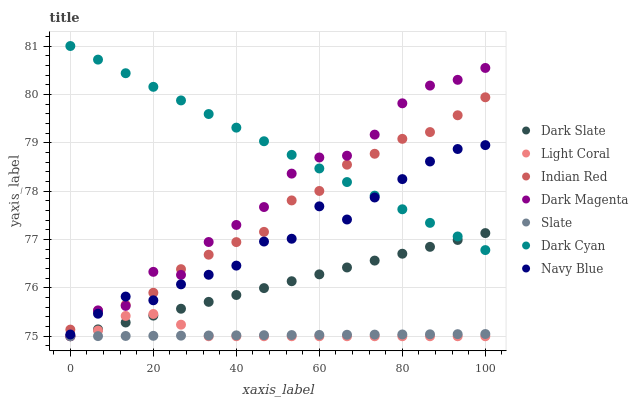Does Slate have the minimum area under the curve?
Answer yes or no. Yes. Does Dark Cyan have the maximum area under the curve?
Answer yes or no. Yes. Does Navy Blue have the minimum area under the curve?
Answer yes or no. No. Does Navy Blue have the maximum area under the curve?
Answer yes or no. No. Is Dark Cyan the smoothest?
Answer yes or no. Yes. Is Dark Magenta the roughest?
Answer yes or no. Yes. Is Navy Blue the smoothest?
Answer yes or no. No. Is Navy Blue the roughest?
Answer yes or no. No. Does Slate have the lowest value?
Answer yes or no. Yes. Does Navy Blue have the lowest value?
Answer yes or no. No. Does Dark Cyan have the highest value?
Answer yes or no. Yes. Does Navy Blue have the highest value?
Answer yes or no. No. Is Slate less than Indian Red?
Answer yes or no. Yes. Is Navy Blue greater than Slate?
Answer yes or no. Yes. Does Slate intersect Dark Slate?
Answer yes or no. Yes. Is Slate less than Dark Slate?
Answer yes or no. No. Is Slate greater than Dark Slate?
Answer yes or no. No. Does Slate intersect Indian Red?
Answer yes or no. No. 